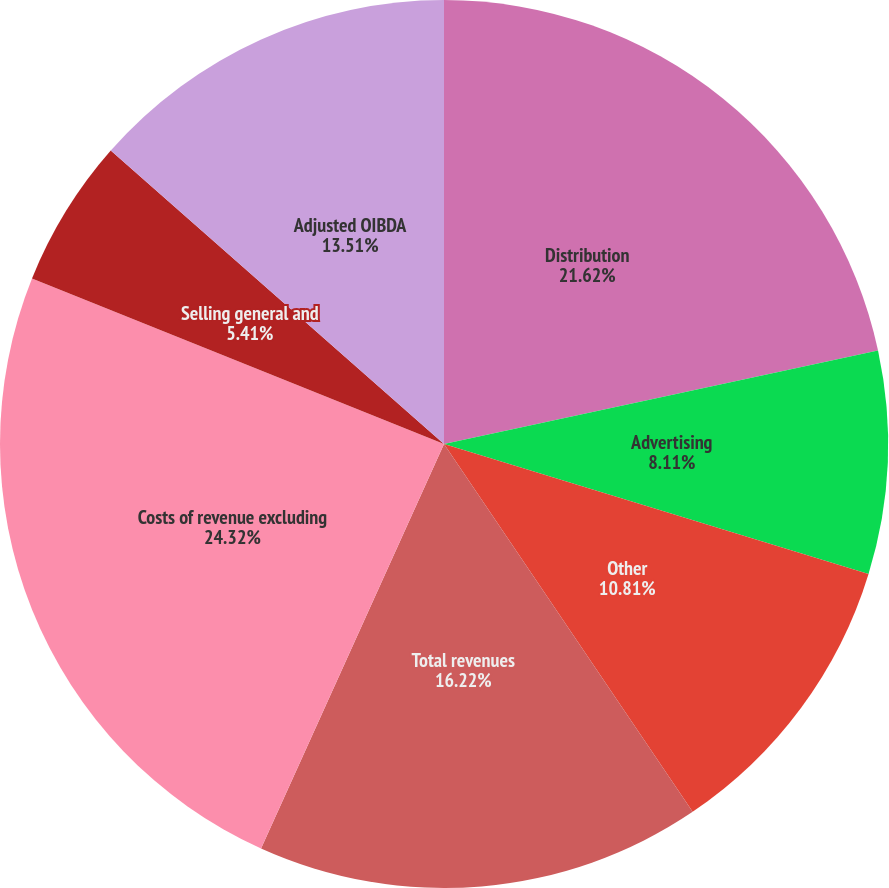<chart> <loc_0><loc_0><loc_500><loc_500><pie_chart><fcel>Distribution<fcel>Advertising<fcel>Other<fcel>Total revenues<fcel>Costs of revenue excluding<fcel>Selling general and<fcel>Adjusted OIBDA<nl><fcel>21.62%<fcel>8.11%<fcel>10.81%<fcel>16.22%<fcel>24.32%<fcel>5.41%<fcel>13.51%<nl></chart> 